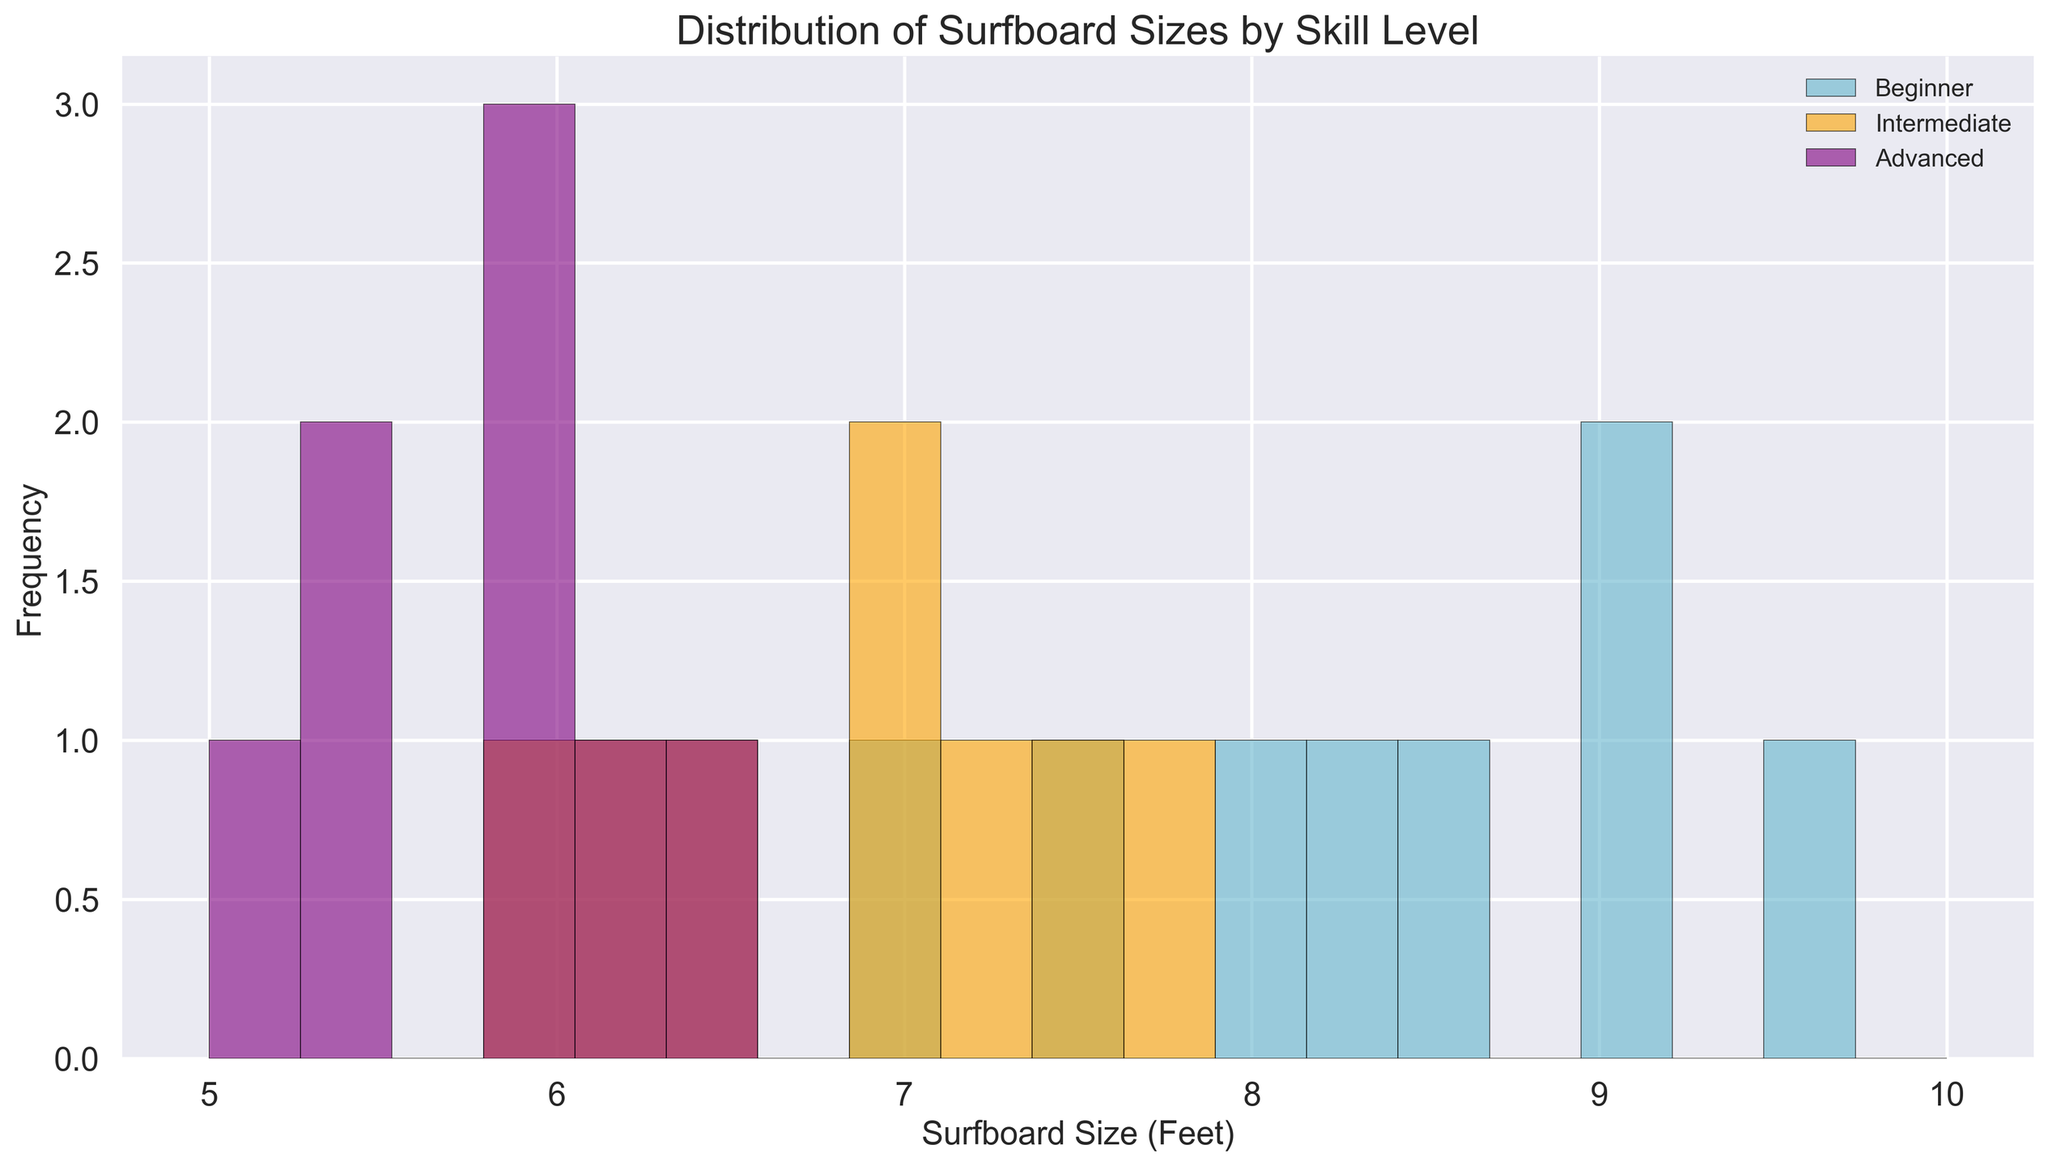How many surfboard sizes are in the range of 8.0 to 9.0 feet for beginners? To find this, locate the bars for beginner surfboard sizes between 8.0 and 9.0 feet and sum their heights.
Answer: 3 Which skill level has the most common surfboard size around 7.5 feet? Look at the histogram bar centered around the 7.5 feet mark and identify which skill level has the highest bar.
Answer: Beginner Do intermediate surfers prefer smaller or larger surfboards compared to advanced surfers? Compare the overlapping regions of both histograms. Intermediate surfers mostly use sizes between 6.0 to 7.8 feet, whereas advanced surfers mainly use sizes between 5.0 to 6.5 feet. Intermediate surfers prefer slightly larger surfboards.
Answer: Larger What's the range of surfboard sizes used by advanced surfers? Advanced surfers use surfboards ranging from the smallest to the largest bar within their category. Locate the smallest and largest values at the bar edges.
Answer: 5.0 - 6.5 feet Between beginners and intermediates, who has a wider variety of surfboard sizes? Compare the spread of bars for beginners and intermediates. Beginners have bars ranging from 7.0 to 9.5 feet, while intermediates range from 6.0 to 7.8 feet.
Answer: Beginners Which skill level has the least number of surfers using sizes below 7.0 feet? Count the bars below the 7.0 feet mark in each category. Advanced has higher frequencies below 7.0 feet than intermediates, and beginners have none below 7.0 feet.
Answer: Beginner What is the most frequent surfboard size range for beginners? Identify the range where the tallest histogram bar(s) for beginners are located. It peaks at 7.5 to 8.5 feet.
Answer: 8.0 - 9.0 feet Do beginners or advanced surfers have more consistent surfboard size preferences (less spread)? Beginners have bars spread from 7.0 to 9.5 feet, whereas advanced surfers have bars from 5.0 to 6.5 feet. Advanced surfers have a smaller range.
Answer: Advanced How does the frequency of surfboard sizes around 6.0 feet compare between intermediate and advanced surfers? Compare the heights of bars for intermediate and advanced surfers around the 6.0 feet mark. Advanced surfers have taller bars around 6.0 feet.
Answer: Advanced Are there any surfboard sizes that are used equally across all skill levels? Check for overlap in bars of equal height across all skill levels; there are no exact bars of equal height.
Answer: No 